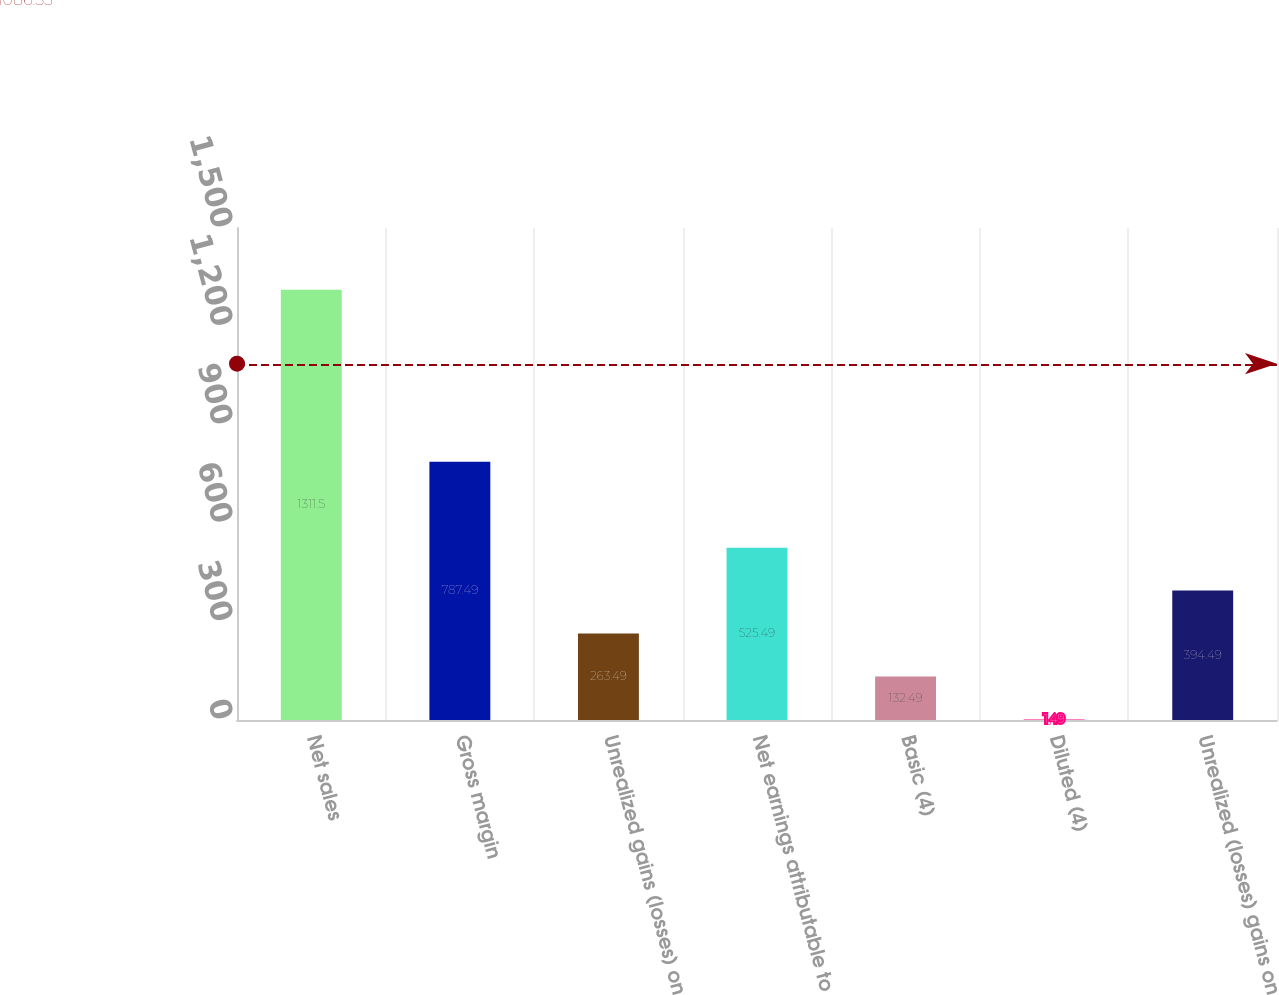<chart> <loc_0><loc_0><loc_500><loc_500><bar_chart><fcel>Net sales<fcel>Gross margin<fcel>Unrealized gains (losses) on<fcel>Net earnings attributable to<fcel>Basic (4)<fcel>Diluted (4)<fcel>Unrealized (losses) gains on<nl><fcel>1311.5<fcel>787.49<fcel>263.49<fcel>525.49<fcel>132.49<fcel>1.49<fcel>394.49<nl></chart> 